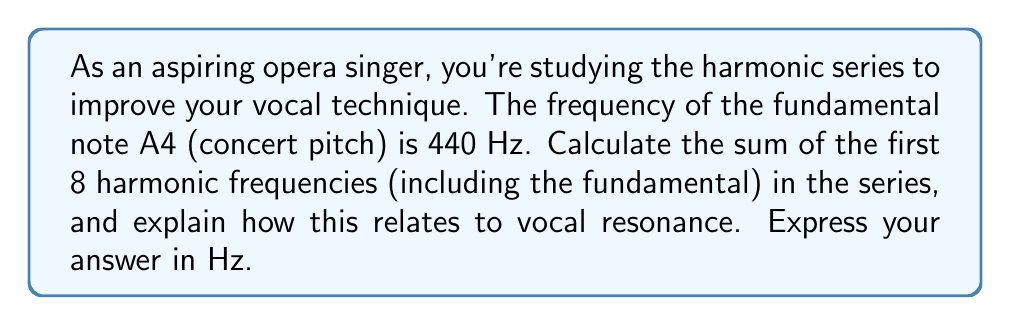Can you solve this math problem? Let's approach this step-by-step:

1) The harmonic series is defined as:
   $$f_n = nf_1$$
   where $f_1$ is the fundamental frequency and $n$ is the harmonic number.

2) Given that A4 has a frequency of 440 Hz, we can list the first 8 harmonics:
   
   $f_1 = 440$ Hz
   $f_2 = 2(440) = 880$ Hz
   $f_3 = 3(440) = 1320$ Hz
   $f_4 = 4(440) = 1760$ Hz
   $f_5 = 5(440) = 2200$ Hz
   $f_6 = 6(440) = 2640$ Hz
   $f_7 = 7(440) = 3080$ Hz
   $f_8 = 8(440) = 3520$ Hz

3) To find the sum, we add these frequencies:

   $$\sum_{n=1}^{8} f_n = 440 + 880 + 1320 + 1760 + 2200 + 2640 + 3080 + 3520$$

4) This sum can be simplified using the formula for the sum of an arithmetic sequence:

   $$\sum_{n=1}^{8} nf_1 = f_1 \sum_{n=1}^{8} n = f_1 \cdot \frac{8(8+1)}{2} = 440 \cdot \frac{8(9)}{2} = 440 \cdot 36 = 15840$$

5) Relation to vocal resonance:
   In singing, the harmonic series plays a crucial role in determining the timbre and resonance of the voice. The vocal tract acts as a resonator, enhancing certain harmonics while dampening others. Understanding the harmonic series helps singers manipulate their vocal tract to emphasize desired harmonics, creating a richer, more resonant tone. The sum we calculated represents the total vibrational energy present in the first 8 harmonics, which contributes to the overall power and richness of the sung note.
Answer: 15840 Hz 